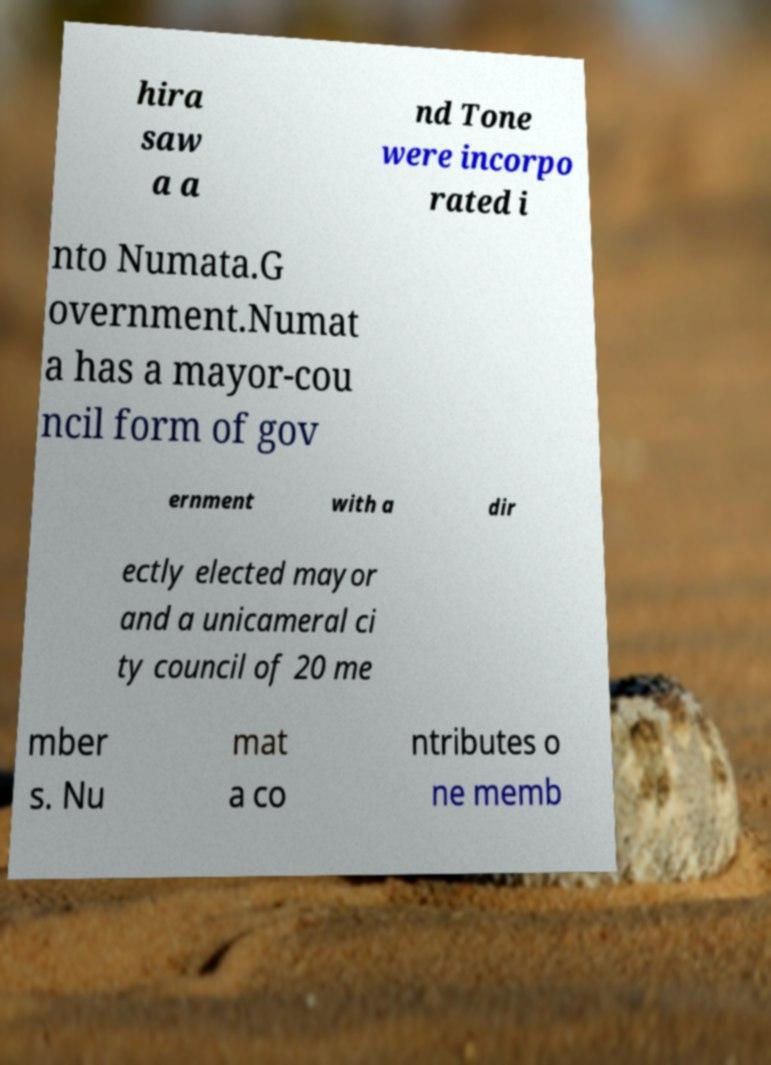Can you accurately transcribe the text from the provided image for me? hira saw a a nd Tone were incorpo rated i nto Numata.G overnment.Numat a has a mayor-cou ncil form of gov ernment with a dir ectly elected mayor and a unicameral ci ty council of 20 me mber s. Nu mat a co ntributes o ne memb 